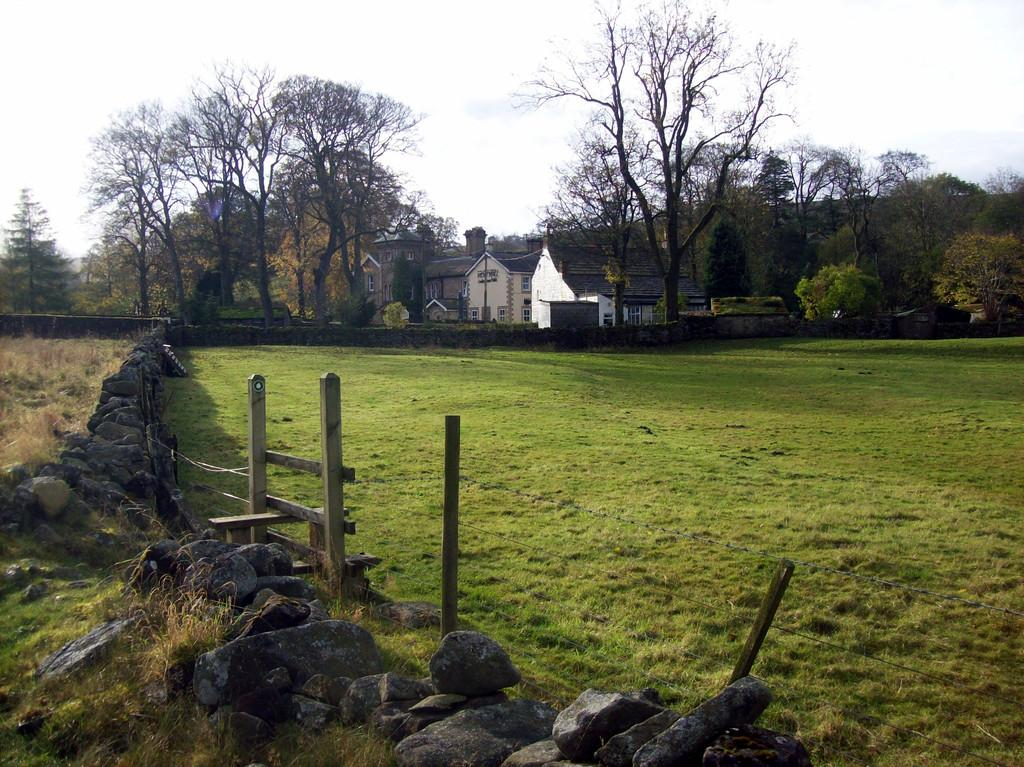What type of structures can be seen in the image? There are roofs of houses in the image. What natural elements are present in the image? There are trees, stones, grass, and the sky visible in the image. What man-made structures can be seen in the image? There is a fence and a wall in the image. How many horses are present in the image? There are no horses present in the image. What type of plantation can be seen in the image? There is no plantation present in the image. 